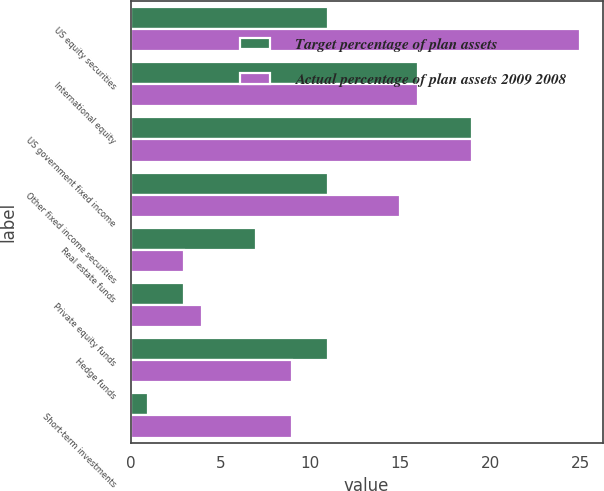<chart> <loc_0><loc_0><loc_500><loc_500><stacked_bar_chart><ecel><fcel>US equity securities<fcel>International equity<fcel>US government fixed income<fcel>Other fixed income securities<fcel>Real estate funds<fcel>Private equity funds<fcel>Hedge funds<fcel>Short-term investments<nl><fcel>Target percentage of plan assets<fcel>11<fcel>16<fcel>19<fcel>11<fcel>7<fcel>3<fcel>11<fcel>1<nl><fcel>Actual percentage of plan assets 2009 2008<fcel>25<fcel>16<fcel>19<fcel>15<fcel>3<fcel>4<fcel>9<fcel>9<nl></chart> 